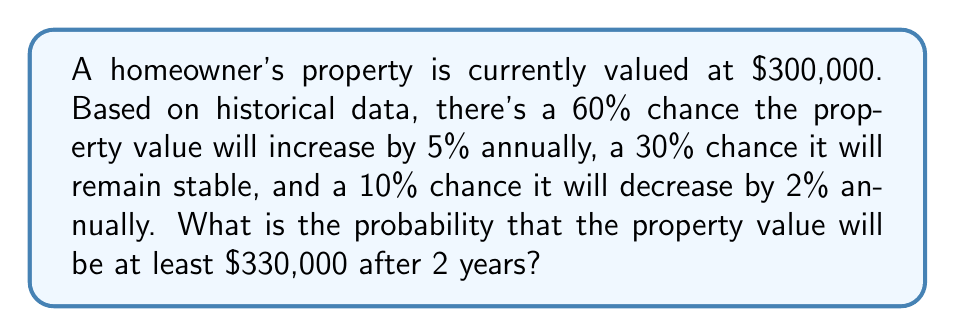Give your solution to this math problem. Let's approach this step-by-step:

1) First, we need to calculate the possible property values after 2 years:

   a) If it increases by 5% each year:
      $300,000 * (1.05)^2 = $330,750$

   b) If it remains stable:
      $300,000$

   c) If it decreases by 2% each year:
      $300,000 * (0.98)^2 = $288,120$

2) The question asks for the probability of the value being at least $330,000. From our calculations, only scenario (a) meets this criterion.

3) To find the probability of scenario (a) occurring, we need to calculate the chance of the property value increasing by 5% for two consecutive years:

   $P(\text{5% increase for 2 years}) = 0.60 * 0.60 = 0.36$

4) Therefore, the probability of the property value being at least $330,000 after 2 years is 0.36 or 36%.
Answer: 0.36 